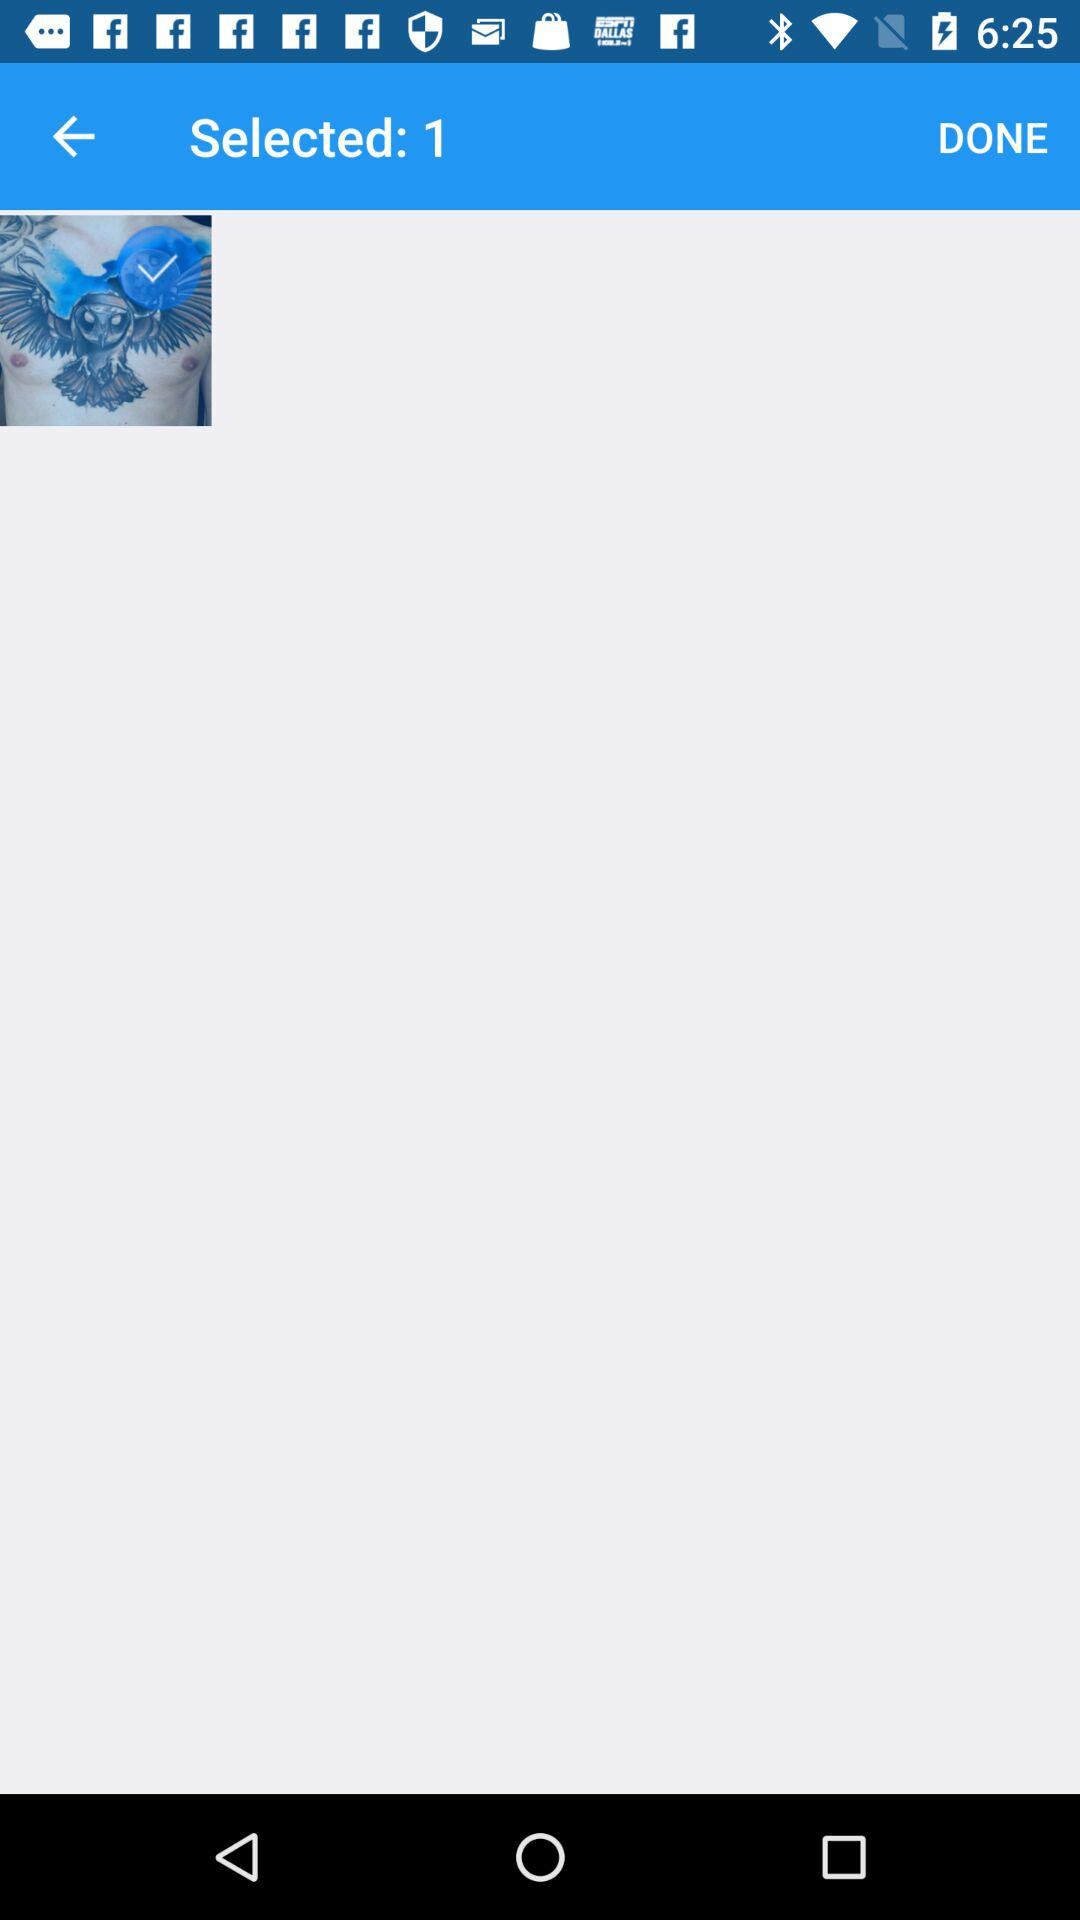How many selected images are there? There is 1 selected image. 